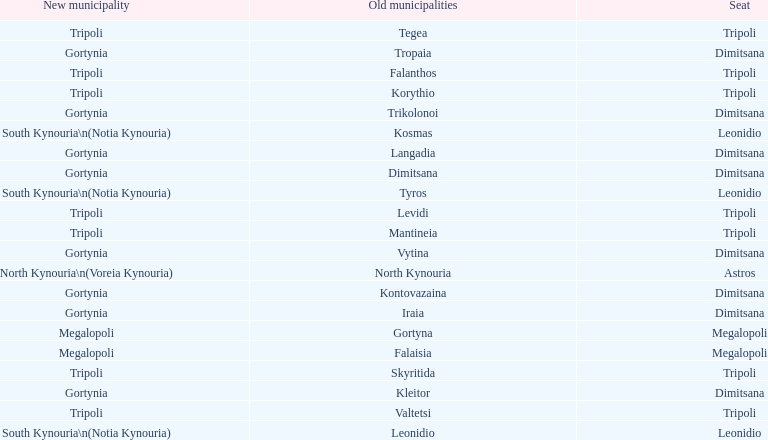When arcadia was reformed in 2011, how many municipalities were created? 5. 